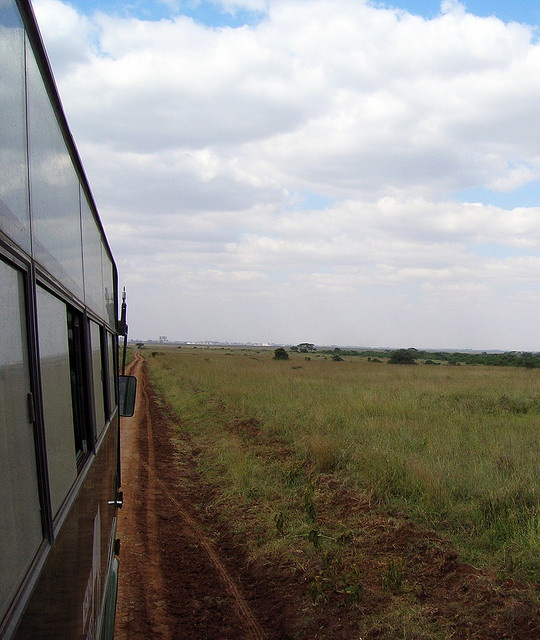Describe the objects in this image and their specific colors. I can see bus in gray, black, and darkgray tones in this image. 